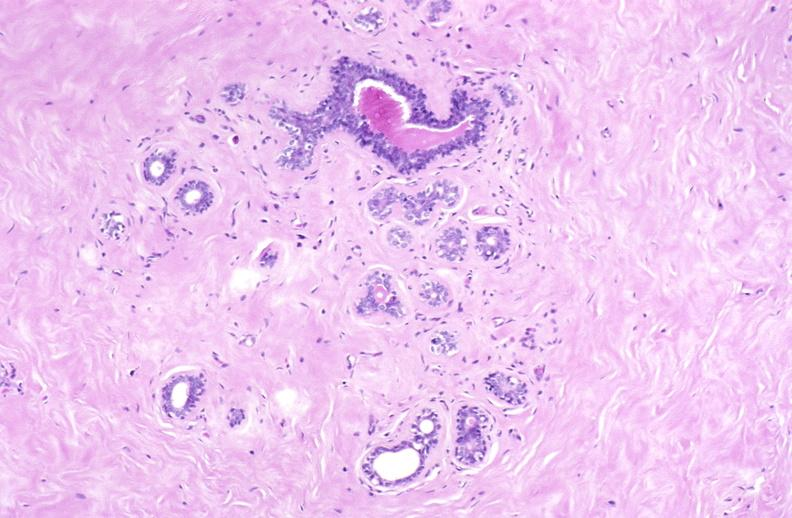where is this area in the body?
Answer the question using a single word or phrase. Breast 